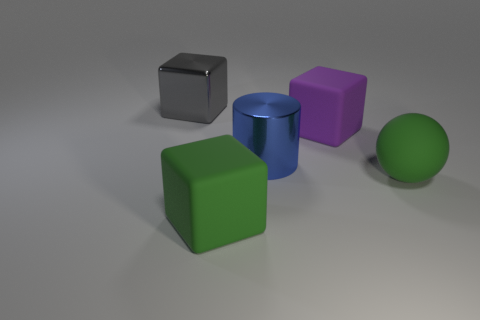Subtract all large gray cubes. How many cubes are left? 2 Add 3 metal blocks. How many objects exist? 8 Subtract all purple blocks. How many blocks are left? 2 Subtract all blocks. How many objects are left? 2 Add 4 large green spheres. How many large green spheres are left? 5 Add 4 large purple rubber objects. How many large purple rubber objects exist? 5 Subtract 0 red cylinders. How many objects are left? 5 Subtract 2 blocks. How many blocks are left? 1 Subtract all red cylinders. Subtract all purple blocks. How many cylinders are left? 1 Subtract all blue balls. How many cyan cylinders are left? 0 